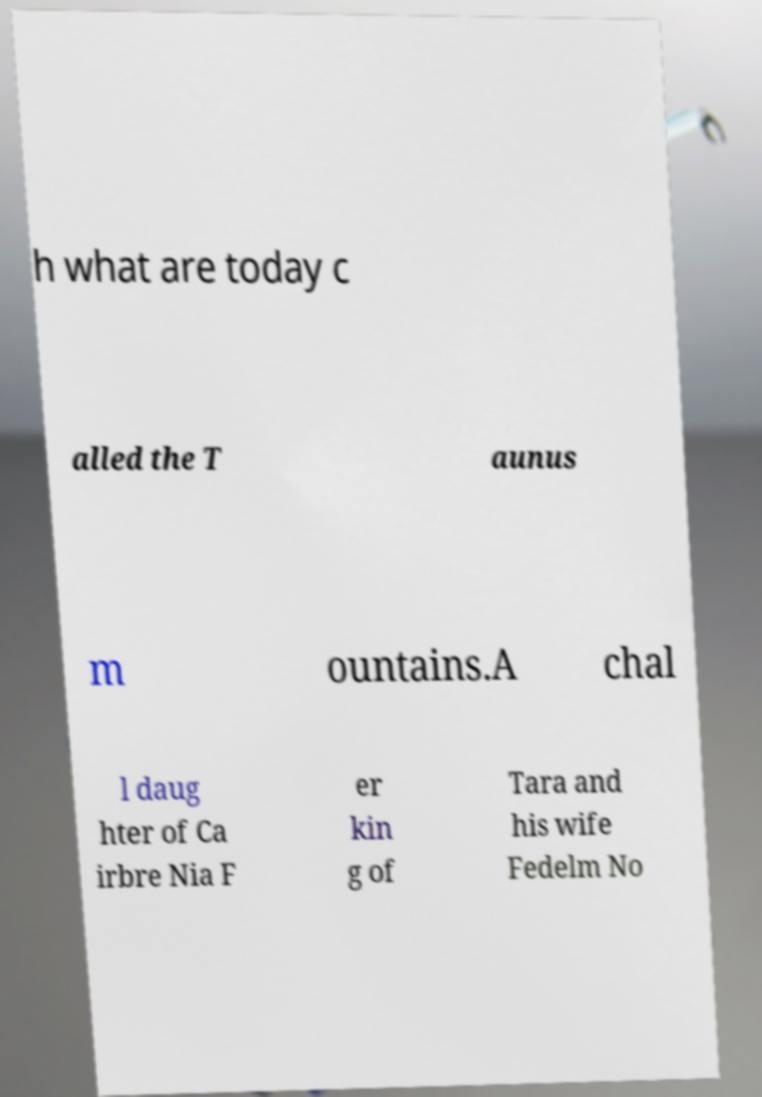Can you accurately transcribe the text from the provided image for me? h what are today c alled the T aunus m ountains.A chal l daug hter of Ca irbre Nia F er kin g of Tara and his wife Fedelm No 